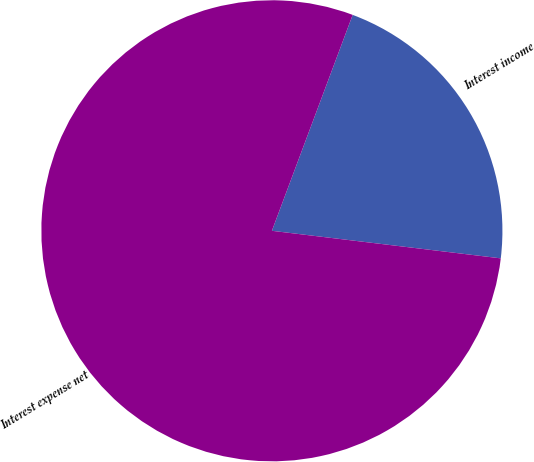<chart> <loc_0><loc_0><loc_500><loc_500><pie_chart><fcel>Interest income<fcel>Interest expense net<nl><fcel>21.21%<fcel>78.79%<nl></chart> 